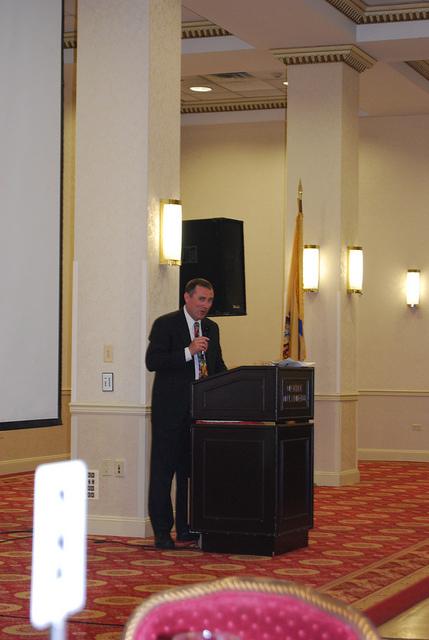Is the television on or off?
Answer briefly. Off. How many sconces are visible?
Keep it brief. 4. What color is the flag?
Keep it brief. Yellow. What is this person standing behind of?
Concise answer only. Podium. What is the man leaning on?
Keep it brief. Podium. 